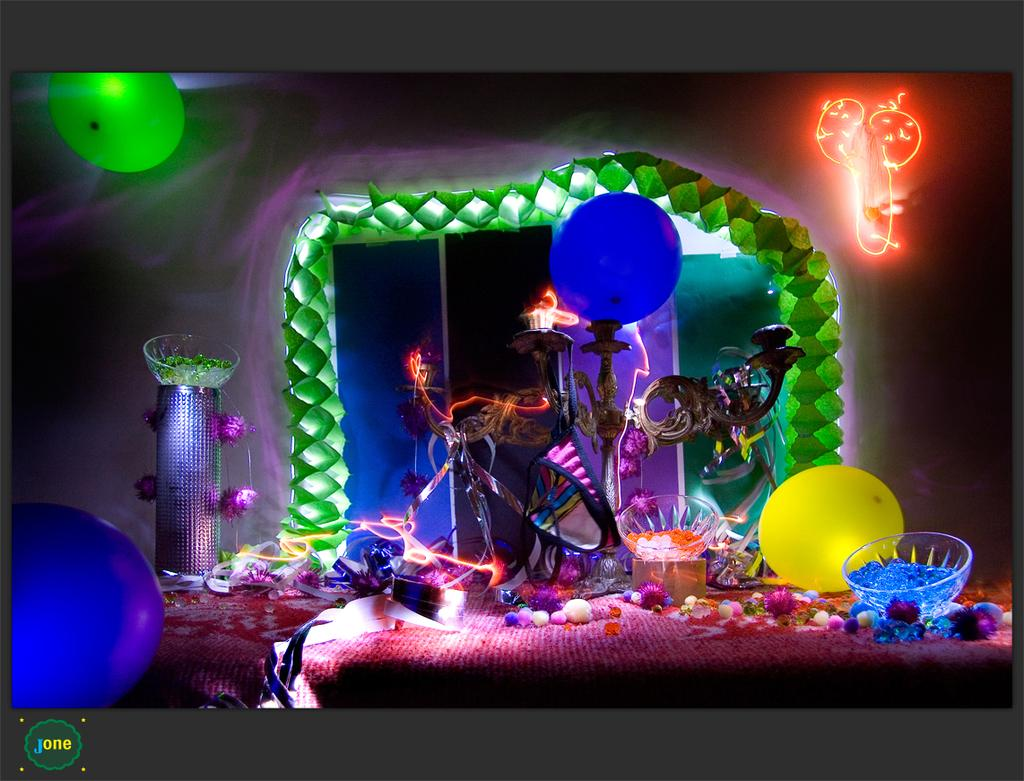What type of objects are floating in the image? There are balloons in the image. What type of containers are visible in the image? There are bowls in the image, including a bowl on a stand. What type of storage container is present in the image? There is a box in the image. What type of objects are used for decoration in the image? There are decorative items in the image. What type of book is being used as a religious symbol in the image? There is no book or religious symbol present in the image. 